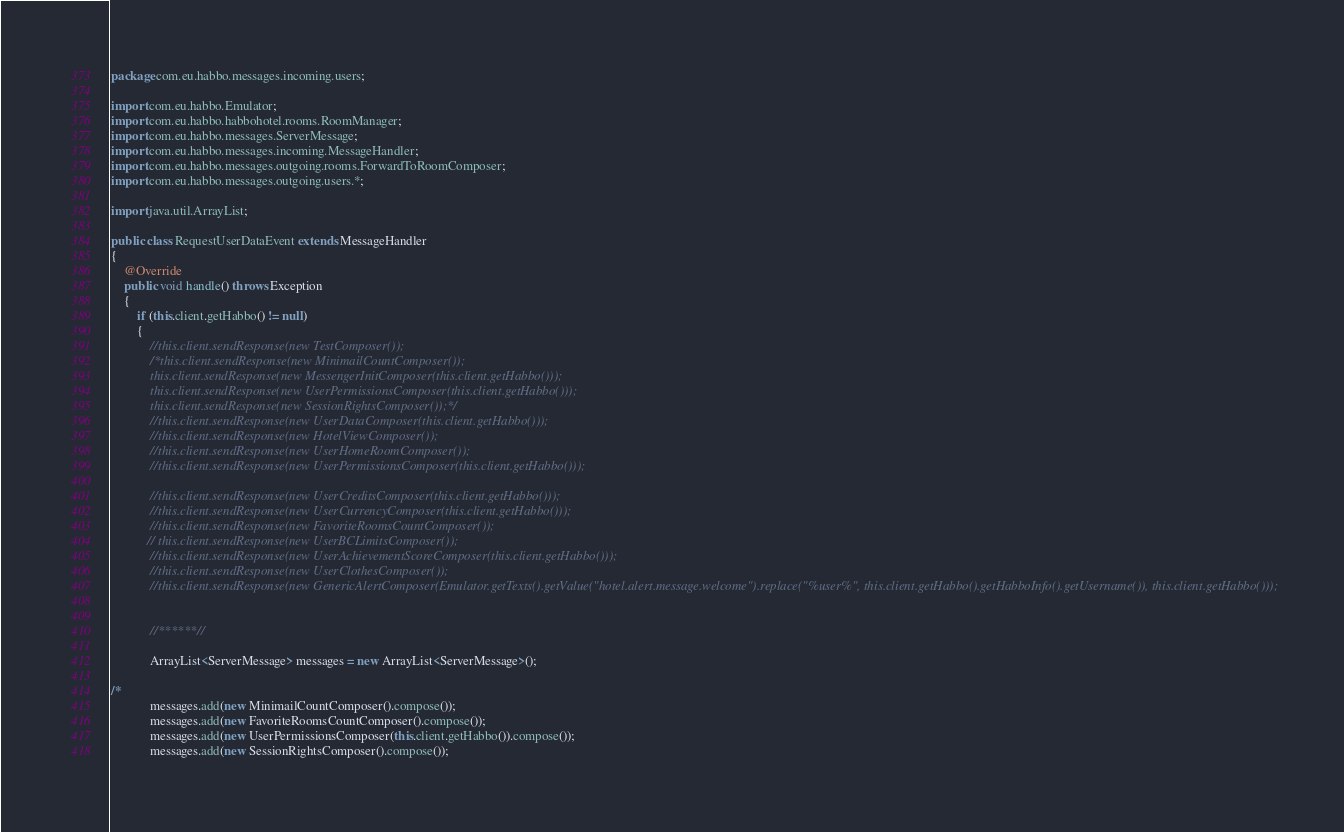<code> <loc_0><loc_0><loc_500><loc_500><_Java_>package com.eu.habbo.messages.incoming.users;

import com.eu.habbo.Emulator;
import com.eu.habbo.habbohotel.rooms.RoomManager;
import com.eu.habbo.messages.ServerMessage;
import com.eu.habbo.messages.incoming.MessageHandler;
import com.eu.habbo.messages.outgoing.rooms.ForwardToRoomComposer;
import com.eu.habbo.messages.outgoing.users.*;

import java.util.ArrayList;

public class RequestUserDataEvent extends MessageHandler
{
    @Override
    public void handle() throws Exception
    {
        if (this.client.getHabbo() != null)
        {
            //this.client.sendResponse(new TestComposer());
            /*this.client.sendResponse(new MinimailCountComposer());
            this.client.sendResponse(new MessengerInitComposer(this.client.getHabbo()));
            this.client.sendResponse(new UserPermissionsComposer(this.client.getHabbo()));
            this.client.sendResponse(new SessionRightsComposer());*/
            //this.client.sendResponse(new UserDataComposer(this.client.getHabbo()));
            //this.client.sendResponse(new HotelViewComposer());
            //this.client.sendResponse(new UserHomeRoomComposer());
            //this.client.sendResponse(new UserPermissionsComposer(this.client.getHabbo()));

            //this.client.sendResponse(new UserCreditsComposer(this.client.getHabbo()));
            //this.client.sendResponse(new UserCurrencyComposer(this.client.getHabbo()));
            //this.client.sendResponse(new FavoriteRoomsCountComposer());
           // this.client.sendResponse(new UserBCLimitsComposer());
            //this.client.sendResponse(new UserAchievementScoreComposer(this.client.getHabbo()));
            //this.client.sendResponse(new UserClothesComposer());
            //this.client.sendResponse(new GenericAlertComposer(Emulator.getTexts().getValue("hotel.alert.message.welcome").replace("%user%", this.client.getHabbo().getHabboInfo().getUsername()), this.client.getHabbo()));


            //******//

            ArrayList<ServerMessage> messages = new ArrayList<ServerMessage>();

/*
            messages.add(new MinimailCountComposer().compose());
            messages.add(new FavoriteRoomsCountComposer().compose());
            messages.add(new UserPermissionsComposer(this.client.getHabbo()).compose());
            messages.add(new SessionRightsComposer().compose());</code> 